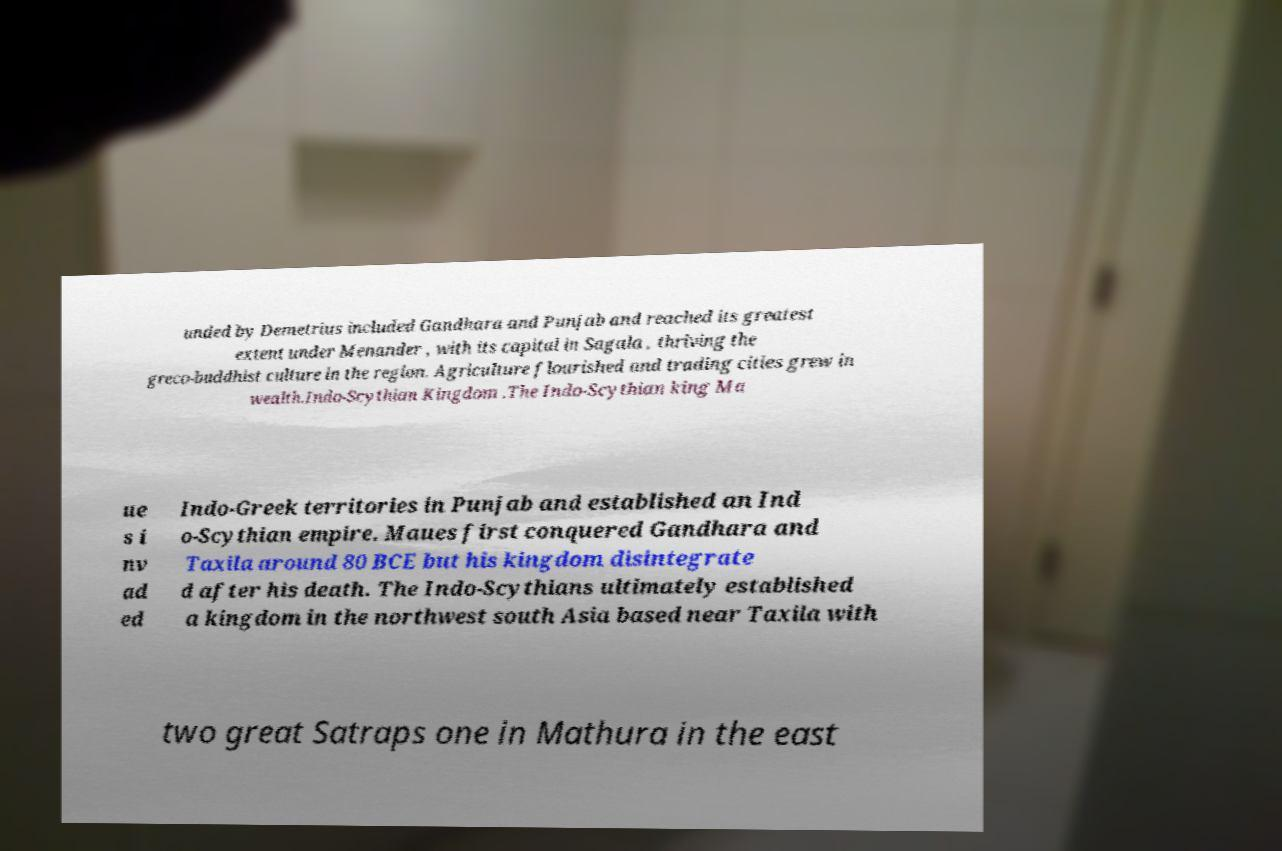Could you extract and type out the text from this image? unded by Demetrius included Gandhara and Punjab and reached its greatest extent under Menander , with its capital in Sagala , thriving the greco-buddhist culture in the region. Agriculture flourished and trading cities grew in wealth.Indo-Scythian Kingdom .The Indo-Scythian king Ma ue s i nv ad ed Indo-Greek territories in Punjab and established an Ind o-Scythian empire. Maues first conquered Gandhara and Taxila around 80 BCE but his kingdom disintegrate d after his death. The Indo-Scythians ultimately established a kingdom in the northwest south Asia based near Taxila with two great Satraps one in Mathura in the east 